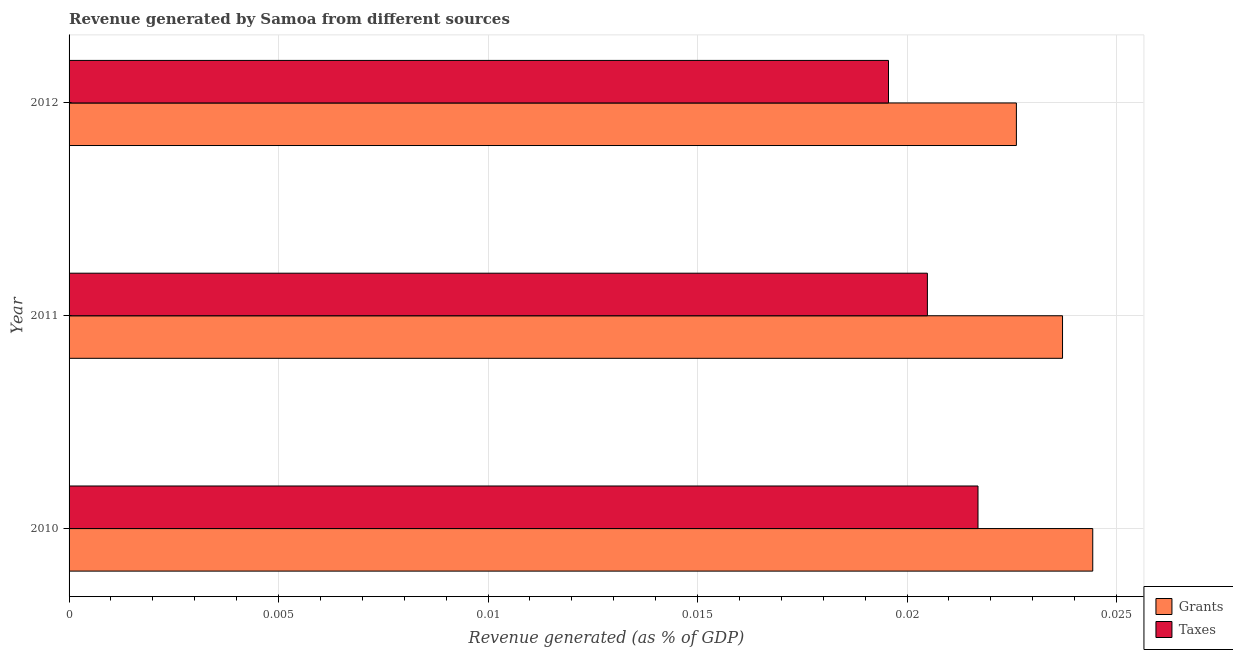How many different coloured bars are there?
Your answer should be compact. 2. How many groups of bars are there?
Your answer should be very brief. 3. How many bars are there on the 3rd tick from the top?
Ensure brevity in your answer.  2. How many bars are there on the 3rd tick from the bottom?
Offer a terse response. 2. What is the revenue generated by grants in 2010?
Offer a terse response. 0.02. Across all years, what is the maximum revenue generated by taxes?
Offer a terse response. 0.02. Across all years, what is the minimum revenue generated by grants?
Keep it short and to the point. 0.02. In which year was the revenue generated by taxes minimum?
Your response must be concise. 2012. What is the total revenue generated by grants in the graph?
Keep it short and to the point. 0.07. What is the difference between the revenue generated by taxes in 2011 and that in 2012?
Offer a very short reply. 0. What is the difference between the revenue generated by grants in 2010 and the revenue generated by taxes in 2012?
Give a very brief answer. 0. What is the average revenue generated by taxes per year?
Keep it short and to the point. 0.02. In the year 2011, what is the difference between the revenue generated by grants and revenue generated by taxes?
Your answer should be compact. 0. In how many years, is the revenue generated by grants greater than 0.018 %?
Your answer should be compact. 3. What is the ratio of the revenue generated by grants in 2011 to that in 2012?
Your answer should be compact. 1.05. Is the difference between the revenue generated by grants in 2011 and 2012 greater than the difference between the revenue generated by taxes in 2011 and 2012?
Ensure brevity in your answer.  Yes. What is the difference between the highest and the second highest revenue generated by grants?
Offer a very short reply. 0. In how many years, is the revenue generated by taxes greater than the average revenue generated by taxes taken over all years?
Give a very brief answer. 1. Is the sum of the revenue generated by grants in 2010 and 2012 greater than the maximum revenue generated by taxes across all years?
Provide a short and direct response. Yes. What does the 2nd bar from the top in 2010 represents?
Provide a succinct answer. Grants. What does the 1st bar from the bottom in 2010 represents?
Give a very brief answer. Grants. What is the difference between two consecutive major ticks on the X-axis?
Provide a short and direct response. 0.01. Does the graph contain any zero values?
Keep it short and to the point. No. Does the graph contain grids?
Ensure brevity in your answer.  Yes. How many legend labels are there?
Ensure brevity in your answer.  2. How are the legend labels stacked?
Your response must be concise. Vertical. What is the title of the graph?
Provide a short and direct response. Revenue generated by Samoa from different sources. Does "Measles" appear as one of the legend labels in the graph?
Your response must be concise. No. What is the label or title of the X-axis?
Your answer should be compact. Revenue generated (as % of GDP). What is the label or title of the Y-axis?
Offer a very short reply. Year. What is the Revenue generated (as % of GDP) of Grants in 2010?
Provide a succinct answer. 0.02. What is the Revenue generated (as % of GDP) of Taxes in 2010?
Provide a succinct answer. 0.02. What is the Revenue generated (as % of GDP) of Grants in 2011?
Give a very brief answer. 0.02. What is the Revenue generated (as % of GDP) of Taxes in 2011?
Make the answer very short. 0.02. What is the Revenue generated (as % of GDP) in Grants in 2012?
Keep it short and to the point. 0.02. What is the Revenue generated (as % of GDP) in Taxes in 2012?
Your answer should be very brief. 0.02. Across all years, what is the maximum Revenue generated (as % of GDP) of Grants?
Your answer should be compact. 0.02. Across all years, what is the maximum Revenue generated (as % of GDP) in Taxes?
Offer a very short reply. 0.02. Across all years, what is the minimum Revenue generated (as % of GDP) of Grants?
Provide a succinct answer. 0.02. Across all years, what is the minimum Revenue generated (as % of GDP) of Taxes?
Provide a short and direct response. 0.02. What is the total Revenue generated (as % of GDP) of Grants in the graph?
Your answer should be compact. 0.07. What is the total Revenue generated (as % of GDP) of Taxes in the graph?
Provide a short and direct response. 0.06. What is the difference between the Revenue generated (as % of GDP) in Grants in 2010 and that in 2011?
Keep it short and to the point. 0. What is the difference between the Revenue generated (as % of GDP) in Taxes in 2010 and that in 2011?
Offer a very short reply. 0. What is the difference between the Revenue generated (as % of GDP) in Grants in 2010 and that in 2012?
Your answer should be very brief. 0. What is the difference between the Revenue generated (as % of GDP) in Taxes in 2010 and that in 2012?
Make the answer very short. 0. What is the difference between the Revenue generated (as % of GDP) in Grants in 2011 and that in 2012?
Make the answer very short. 0. What is the difference between the Revenue generated (as % of GDP) in Taxes in 2011 and that in 2012?
Your response must be concise. 0. What is the difference between the Revenue generated (as % of GDP) in Grants in 2010 and the Revenue generated (as % of GDP) in Taxes in 2011?
Offer a terse response. 0. What is the difference between the Revenue generated (as % of GDP) in Grants in 2010 and the Revenue generated (as % of GDP) in Taxes in 2012?
Ensure brevity in your answer.  0. What is the difference between the Revenue generated (as % of GDP) in Grants in 2011 and the Revenue generated (as % of GDP) in Taxes in 2012?
Offer a terse response. 0. What is the average Revenue generated (as % of GDP) in Grants per year?
Your response must be concise. 0.02. What is the average Revenue generated (as % of GDP) of Taxes per year?
Offer a terse response. 0.02. In the year 2010, what is the difference between the Revenue generated (as % of GDP) in Grants and Revenue generated (as % of GDP) in Taxes?
Provide a short and direct response. 0. In the year 2011, what is the difference between the Revenue generated (as % of GDP) of Grants and Revenue generated (as % of GDP) of Taxes?
Ensure brevity in your answer.  0. In the year 2012, what is the difference between the Revenue generated (as % of GDP) of Grants and Revenue generated (as % of GDP) of Taxes?
Make the answer very short. 0. What is the ratio of the Revenue generated (as % of GDP) in Grants in 2010 to that in 2011?
Your response must be concise. 1.03. What is the ratio of the Revenue generated (as % of GDP) in Taxes in 2010 to that in 2011?
Make the answer very short. 1.06. What is the ratio of the Revenue generated (as % of GDP) of Grants in 2010 to that in 2012?
Provide a short and direct response. 1.08. What is the ratio of the Revenue generated (as % of GDP) of Taxes in 2010 to that in 2012?
Your answer should be very brief. 1.11. What is the ratio of the Revenue generated (as % of GDP) in Grants in 2011 to that in 2012?
Ensure brevity in your answer.  1.05. What is the ratio of the Revenue generated (as % of GDP) of Taxes in 2011 to that in 2012?
Make the answer very short. 1.05. What is the difference between the highest and the second highest Revenue generated (as % of GDP) in Grants?
Give a very brief answer. 0. What is the difference between the highest and the second highest Revenue generated (as % of GDP) of Taxes?
Your answer should be compact. 0. What is the difference between the highest and the lowest Revenue generated (as % of GDP) of Grants?
Keep it short and to the point. 0. What is the difference between the highest and the lowest Revenue generated (as % of GDP) of Taxes?
Your answer should be compact. 0. 